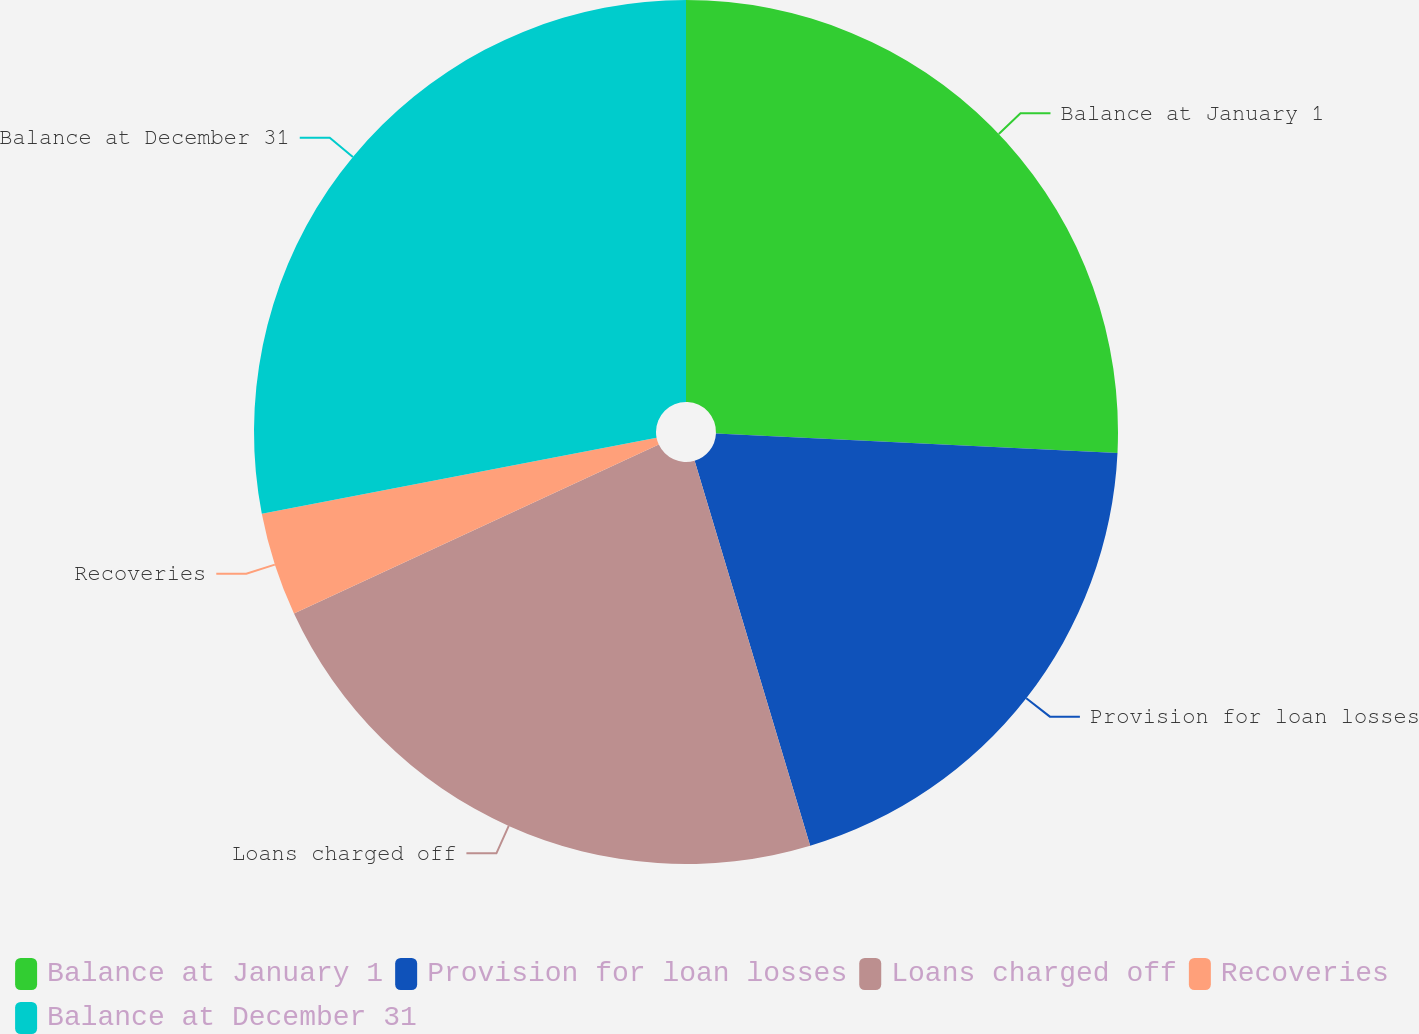<chart> <loc_0><loc_0><loc_500><loc_500><pie_chart><fcel>Balance at January 1<fcel>Provision for loan losses<fcel>Loans charged off<fcel>Recoveries<fcel>Balance at December 31<nl><fcel>25.77%<fcel>19.59%<fcel>22.74%<fcel>3.87%<fcel>28.03%<nl></chart> 